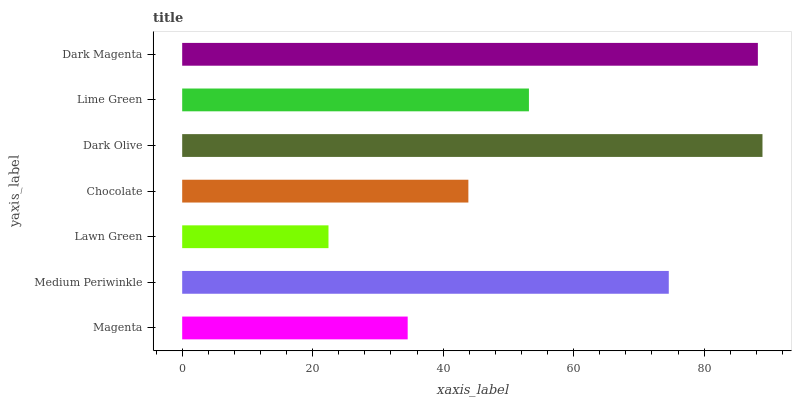Is Lawn Green the minimum?
Answer yes or no. Yes. Is Dark Olive the maximum?
Answer yes or no. Yes. Is Medium Periwinkle the minimum?
Answer yes or no. No. Is Medium Periwinkle the maximum?
Answer yes or no. No. Is Medium Periwinkle greater than Magenta?
Answer yes or no. Yes. Is Magenta less than Medium Periwinkle?
Answer yes or no. Yes. Is Magenta greater than Medium Periwinkle?
Answer yes or no. No. Is Medium Periwinkle less than Magenta?
Answer yes or no. No. Is Lime Green the high median?
Answer yes or no. Yes. Is Lime Green the low median?
Answer yes or no. Yes. Is Magenta the high median?
Answer yes or no. No. Is Dark Magenta the low median?
Answer yes or no. No. 